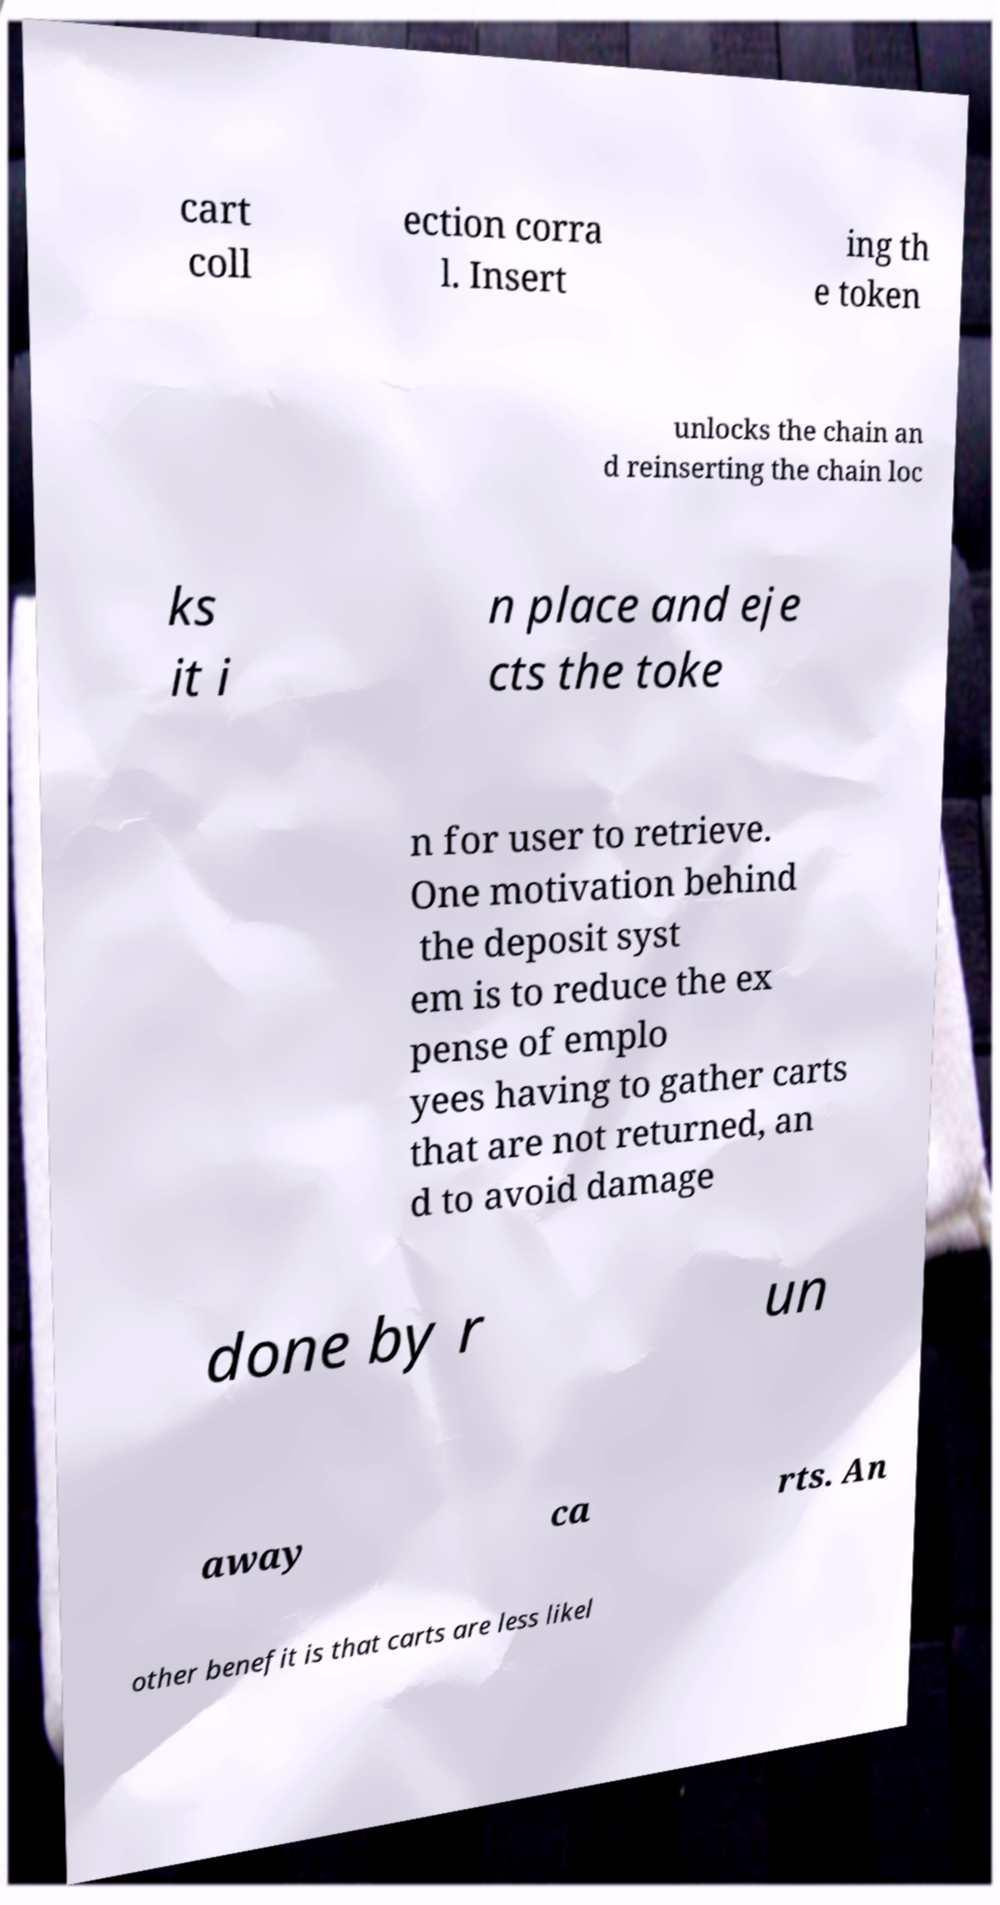What messages or text are displayed in this image? I need them in a readable, typed format. cart coll ection corra l. Insert ing th e token unlocks the chain an d reinserting the chain loc ks it i n place and eje cts the toke n for user to retrieve. One motivation behind the deposit syst em is to reduce the ex pense of emplo yees having to gather carts that are not returned, an d to avoid damage done by r un away ca rts. An other benefit is that carts are less likel 